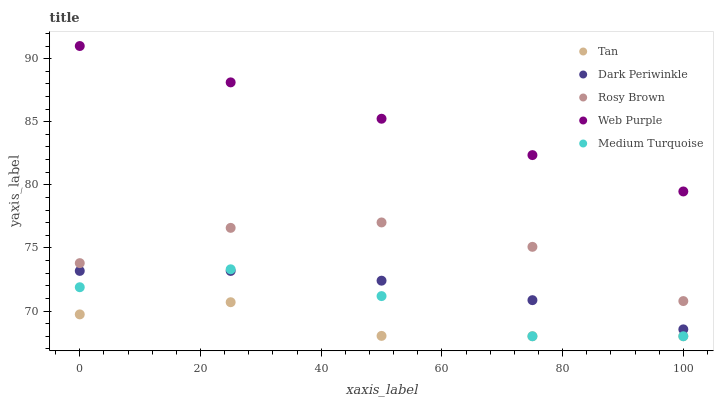Does Tan have the minimum area under the curve?
Answer yes or no. Yes. Does Web Purple have the maximum area under the curve?
Answer yes or no. Yes. Does Rosy Brown have the minimum area under the curve?
Answer yes or no. No. Does Rosy Brown have the maximum area under the curve?
Answer yes or no. No. Is Web Purple the smoothest?
Answer yes or no. Yes. Is Medium Turquoise the roughest?
Answer yes or no. Yes. Is Tan the smoothest?
Answer yes or no. No. Is Tan the roughest?
Answer yes or no. No. Does Tan have the lowest value?
Answer yes or no. Yes. Does Rosy Brown have the lowest value?
Answer yes or no. No. Does Web Purple have the highest value?
Answer yes or no. Yes. Does Rosy Brown have the highest value?
Answer yes or no. No. Is Rosy Brown less than Web Purple?
Answer yes or no. Yes. Is Web Purple greater than Medium Turquoise?
Answer yes or no. Yes. Does Dark Periwinkle intersect Medium Turquoise?
Answer yes or no. Yes. Is Dark Periwinkle less than Medium Turquoise?
Answer yes or no. No. Is Dark Periwinkle greater than Medium Turquoise?
Answer yes or no. No. Does Rosy Brown intersect Web Purple?
Answer yes or no. No. 